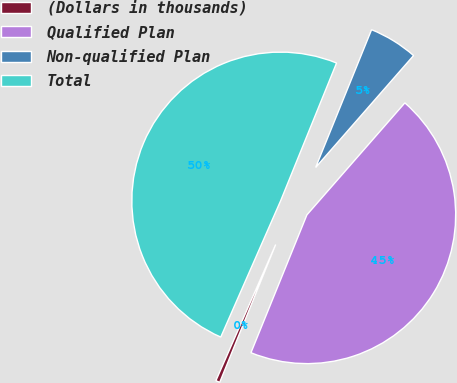Convert chart. <chart><loc_0><loc_0><loc_500><loc_500><pie_chart><fcel>(Dollars in thousands)<fcel>Qualified Plan<fcel>Non-qualified Plan<fcel>Total<nl><fcel>0.45%<fcel>44.7%<fcel>5.3%<fcel>49.55%<nl></chart> 